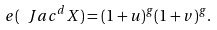Convert formula to latex. <formula><loc_0><loc_0><loc_500><loc_500>e ( \ J a c ^ { d } X ) = ( 1 + u ) ^ { g } ( 1 + v ) ^ { g } .</formula> 